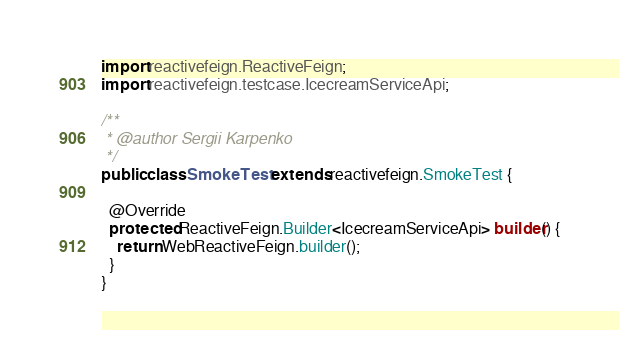Convert code to text. <code><loc_0><loc_0><loc_500><loc_500><_Java_>
import reactivefeign.ReactiveFeign;
import reactivefeign.testcase.IcecreamServiceApi;

/**
 * @author Sergii Karpenko
 */
public class SmokeTest extends reactivefeign.SmokeTest {

  @Override
  protected ReactiveFeign.Builder<IcecreamServiceApi> builder() {
    return WebReactiveFeign.builder();
  }
}
</code> 